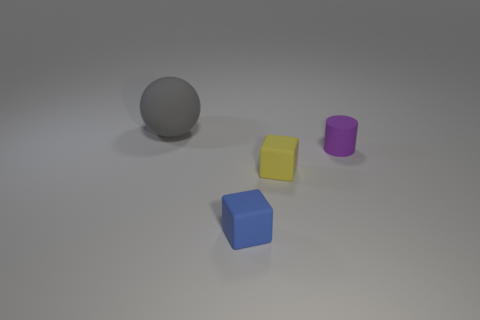Add 4 yellow things. How many objects exist? 8 Subtract all spheres. How many objects are left? 3 Subtract all large green shiny cubes. Subtract all big objects. How many objects are left? 3 Add 2 matte objects. How many matte objects are left? 6 Add 2 gray matte objects. How many gray matte objects exist? 3 Subtract 0 brown cylinders. How many objects are left? 4 